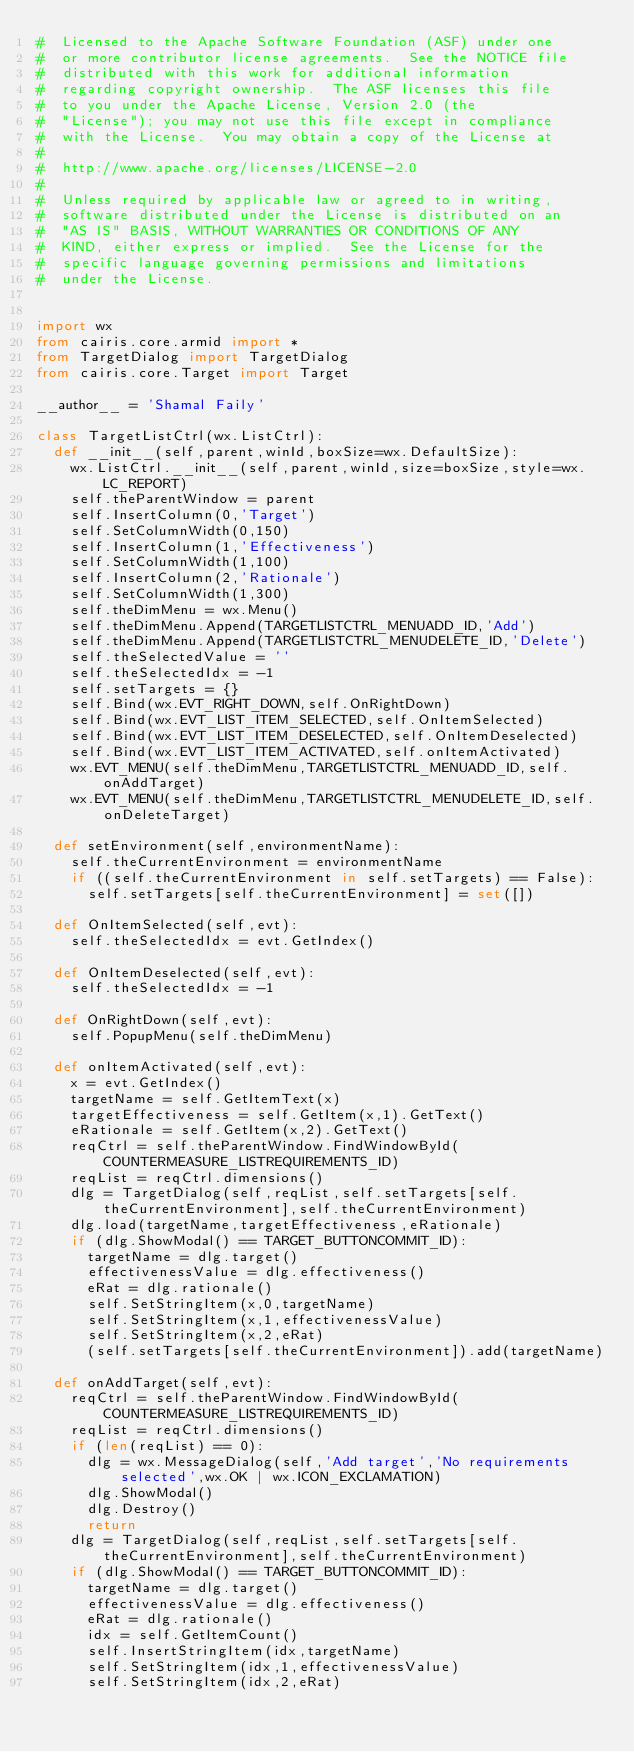<code> <loc_0><loc_0><loc_500><loc_500><_Python_>#  Licensed to the Apache Software Foundation (ASF) under one
#  or more contributor license agreements.  See the NOTICE file
#  distributed with this work for additional information
#  regarding copyright ownership.  The ASF licenses this file
#  to you under the Apache License, Version 2.0 (the
#  "License"); you may not use this file except in compliance
#  with the License.  You may obtain a copy of the License at
#
#  http://www.apache.org/licenses/LICENSE-2.0
#
#  Unless required by applicable law or agreed to in writing,
#  software distributed under the License is distributed on an
#  "AS IS" BASIS, WITHOUT WARRANTIES OR CONDITIONS OF ANY
#  KIND, either express or implied.  See the License for the
#  specific language governing permissions and limitations
#  under the License.


import wx
from cairis.core.armid import *
from TargetDialog import TargetDialog
from cairis.core.Target import Target

__author__ = 'Shamal Faily'

class TargetListCtrl(wx.ListCtrl):
  def __init__(self,parent,winId,boxSize=wx.DefaultSize):
    wx.ListCtrl.__init__(self,parent,winId,size=boxSize,style=wx.LC_REPORT)
    self.theParentWindow = parent
    self.InsertColumn(0,'Target')
    self.SetColumnWidth(0,150)
    self.InsertColumn(1,'Effectiveness')
    self.SetColumnWidth(1,100)
    self.InsertColumn(2,'Rationale')
    self.SetColumnWidth(1,300)
    self.theDimMenu = wx.Menu()
    self.theDimMenu.Append(TARGETLISTCTRL_MENUADD_ID,'Add')
    self.theDimMenu.Append(TARGETLISTCTRL_MENUDELETE_ID,'Delete')
    self.theSelectedValue = ''
    self.theSelectedIdx = -1
    self.setTargets = {}
    self.Bind(wx.EVT_RIGHT_DOWN,self.OnRightDown)
    self.Bind(wx.EVT_LIST_ITEM_SELECTED,self.OnItemSelected)
    self.Bind(wx.EVT_LIST_ITEM_DESELECTED,self.OnItemDeselected)
    self.Bind(wx.EVT_LIST_ITEM_ACTIVATED,self.onItemActivated)
    wx.EVT_MENU(self.theDimMenu,TARGETLISTCTRL_MENUADD_ID,self.onAddTarget)
    wx.EVT_MENU(self.theDimMenu,TARGETLISTCTRL_MENUDELETE_ID,self.onDeleteTarget)

  def setEnvironment(self,environmentName):
    self.theCurrentEnvironment = environmentName
    if ((self.theCurrentEnvironment in self.setTargets) == False):
      self.setTargets[self.theCurrentEnvironment] = set([])
 
  def OnItemSelected(self,evt):
    self.theSelectedIdx = evt.GetIndex()

  def OnItemDeselected(self,evt):
    self.theSelectedIdx = -1

  def OnRightDown(self,evt):
    self.PopupMenu(self.theDimMenu)

  def onItemActivated(self,evt):
    x = evt.GetIndex()
    targetName = self.GetItemText(x)
    targetEffectiveness = self.GetItem(x,1).GetText()
    eRationale = self.GetItem(x,2).GetText()
    reqCtrl = self.theParentWindow.FindWindowById(COUNTERMEASURE_LISTREQUIREMENTS_ID)
    reqList = reqCtrl.dimensions()
    dlg = TargetDialog(self,reqList,self.setTargets[self.theCurrentEnvironment],self.theCurrentEnvironment)
    dlg.load(targetName,targetEffectiveness,eRationale)
    if (dlg.ShowModal() == TARGET_BUTTONCOMMIT_ID):
      targetName = dlg.target()
      effectivenessValue = dlg.effectiveness()
      eRat = dlg.rationale()
      self.SetStringItem(x,0,targetName)
      self.SetStringItem(x,1,effectivenessValue)
      self.SetStringItem(x,2,eRat)
      (self.setTargets[self.theCurrentEnvironment]).add(targetName)

  def onAddTarget(self,evt):
    reqCtrl = self.theParentWindow.FindWindowById(COUNTERMEASURE_LISTREQUIREMENTS_ID)
    reqList = reqCtrl.dimensions()
    if (len(reqList) == 0):
      dlg = wx.MessageDialog(self,'Add target','No requirements selected',wx.OK | wx.ICON_EXCLAMATION)
      dlg.ShowModal()
      dlg.Destroy()
      return
    dlg = TargetDialog(self,reqList,self.setTargets[self.theCurrentEnvironment],self.theCurrentEnvironment)
    if (dlg.ShowModal() == TARGET_BUTTONCOMMIT_ID):
      targetName = dlg.target()
      effectivenessValue = dlg.effectiveness()
      eRat = dlg.rationale()
      idx = self.GetItemCount()
      self.InsertStringItem(idx,targetName)
      self.SetStringItem(idx,1,effectivenessValue)
      self.SetStringItem(idx,2,eRat)</code> 